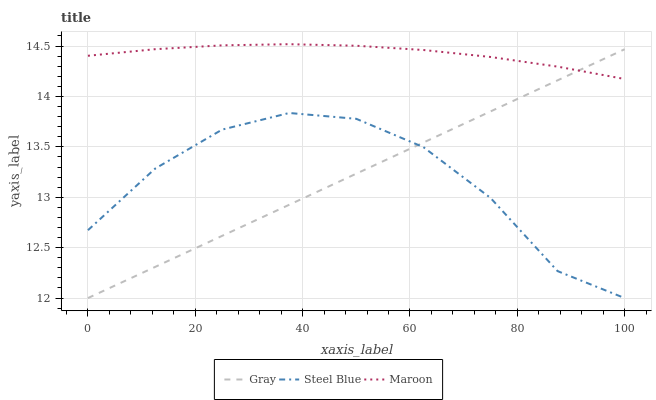Does Steel Blue have the minimum area under the curve?
Answer yes or no. Yes. Does Maroon have the maximum area under the curve?
Answer yes or no. Yes. Does Maroon have the minimum area under the curve?
Answer yes or no. No. Does Steel Blue have the maximum area under the curve?
Answer yes or no. No. Is Gray the smoothest?
Answer yes or no. Yes. Is Steel Blue the roughest?
Answer yes or no. Yes. Is Maroon the smoothest?
Answer yes or no. No. Is Maroon the roughest?
Answer yes or no. No. Does Maroon have the lowest value?
Answer yes or no. No. Does Maroon have the highest value?
Answer yes or no. Yes. Does Steel Blue have the highest value?
Answer yes or no. No. Is Steel Blue less than Maroon?
Answer yes or no. Yes. Is Maroon greater than Steel Blue?
Answer yes or no. Yes. Does Gray intersect Maroon?
Answer yes or no. Yes. Is Gray less than Maroon?
Answer yes or no. No. Is Gray greater than Maroon?
Answer yes or no. No. Does Steel Blue intersect Maroon?
Answer yes or no. No. 